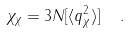<formula> <loc_0><loc_0><loc_500><loc_500>\chi _ { \chi } = 3 N [ \langle q _ { \chi } ^ { 2 } \rangle ] \ \ .</formula> 